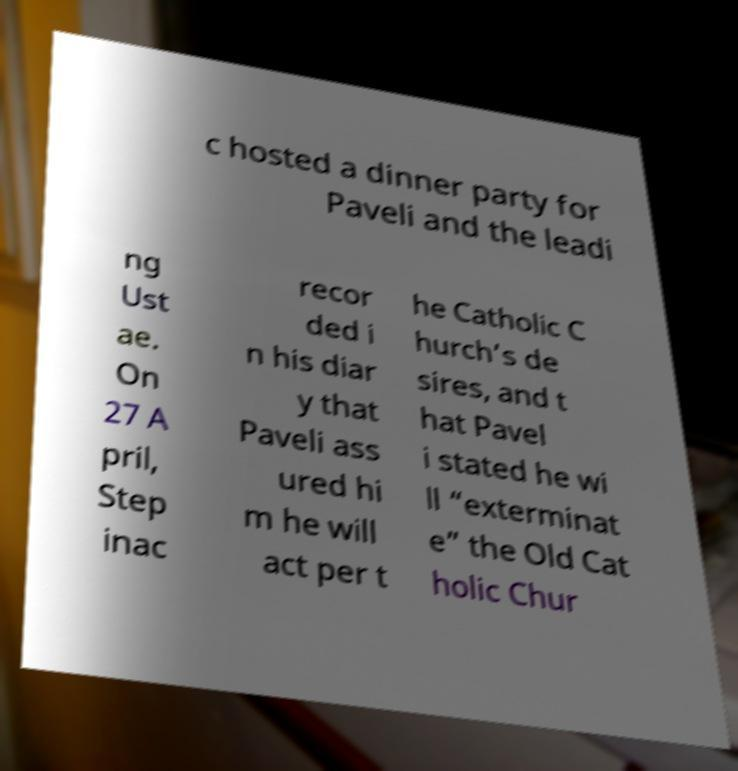I need the written content from this picture converted into text. Can you do that? c hosted a dinner party for Paveli and the leadi ng Ust ae. On 27 A pril, Step inac recor ded i n his diar y that Paveli ass ured hi m he will act per t he Catholic C hurch’s de sires, and t hat Pavel i stated he wi ll “exterminat e” the Old Cat holic Chur 